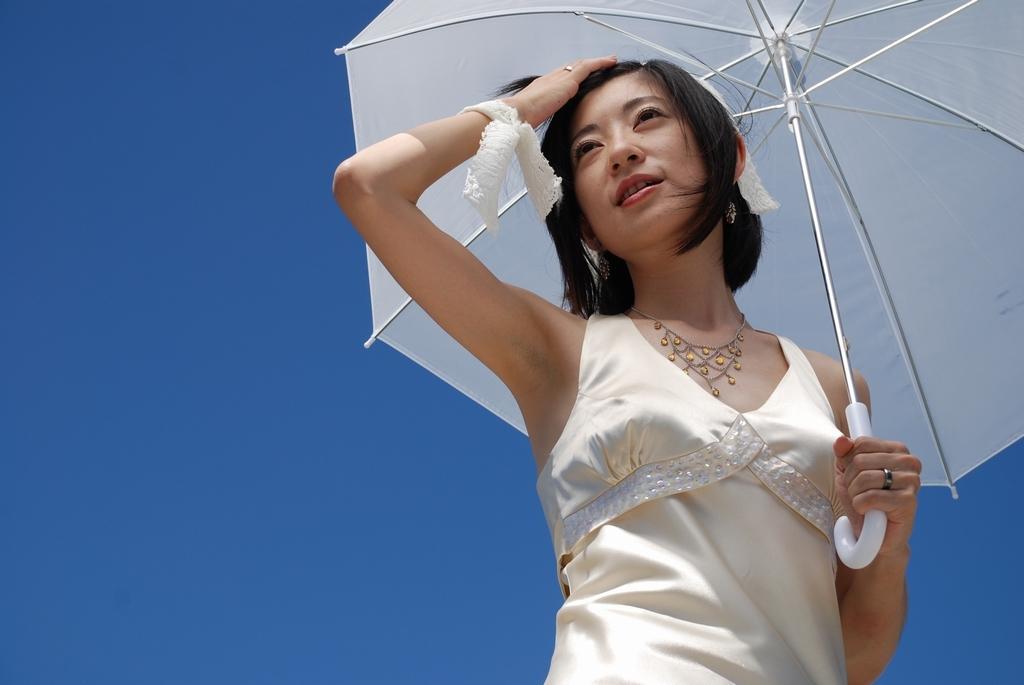Please provide a concise description of this image. In this picture we can see a woman in the dress and the woman is holding an umbrella. Behind the woman there is the sky. 